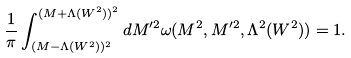<formula> <loc_0><loc_0><loc_500><loc_500>\frac { 1 } { \pi } \int ^ { ( M + \Lambda ( W ^ { 2 } ) ) ^ { 2 } } _ { ( M - \Lambda ( W ^ { 2 } ) ) ^ { 2 } } d M ^ { \prime 2 } \omega ( M ^ { 2 } , M ^ { \prime 2 } , \Lambda ^ { 2 } ( W ^ { 2 } ) ) = 1 .</formula> 